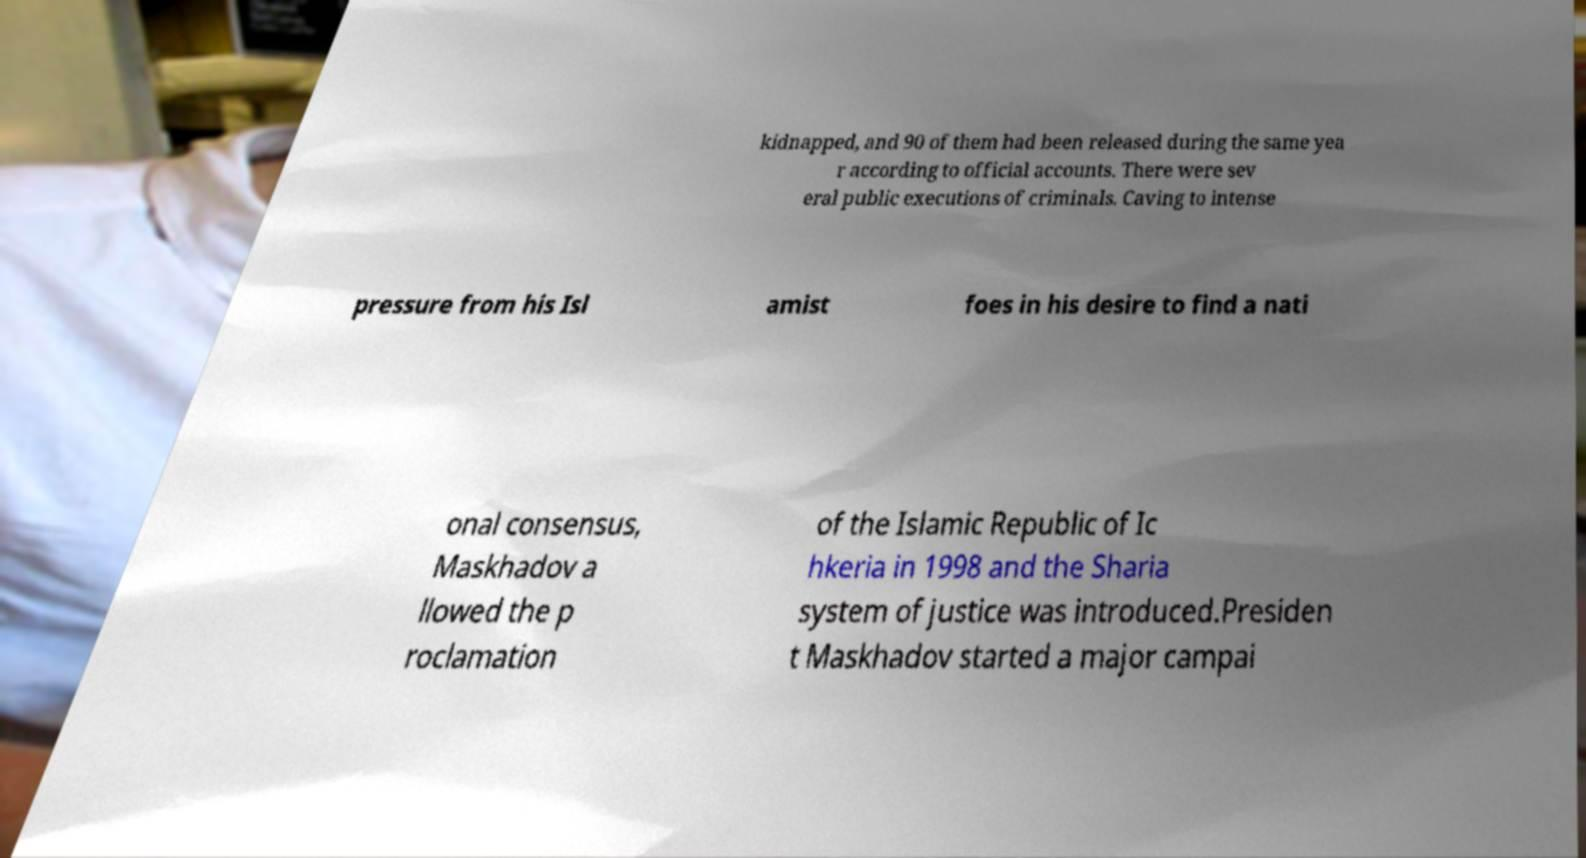I need the written content from this picture converted into text. Can you do that? kidnapped, and 90 of them had been released during the same yea r according to official accounts. There were sev eral public executions of criminals. Caving to intense pressure from his Isl amist foes in his desire to find a nati onal consensus, Maskhadov a llowed the p roclamation of the Islamic Republic of Ic hkeria in 1998 and the Sharia system of justice was introduced.Presiden t Maskhadov started a major campai 